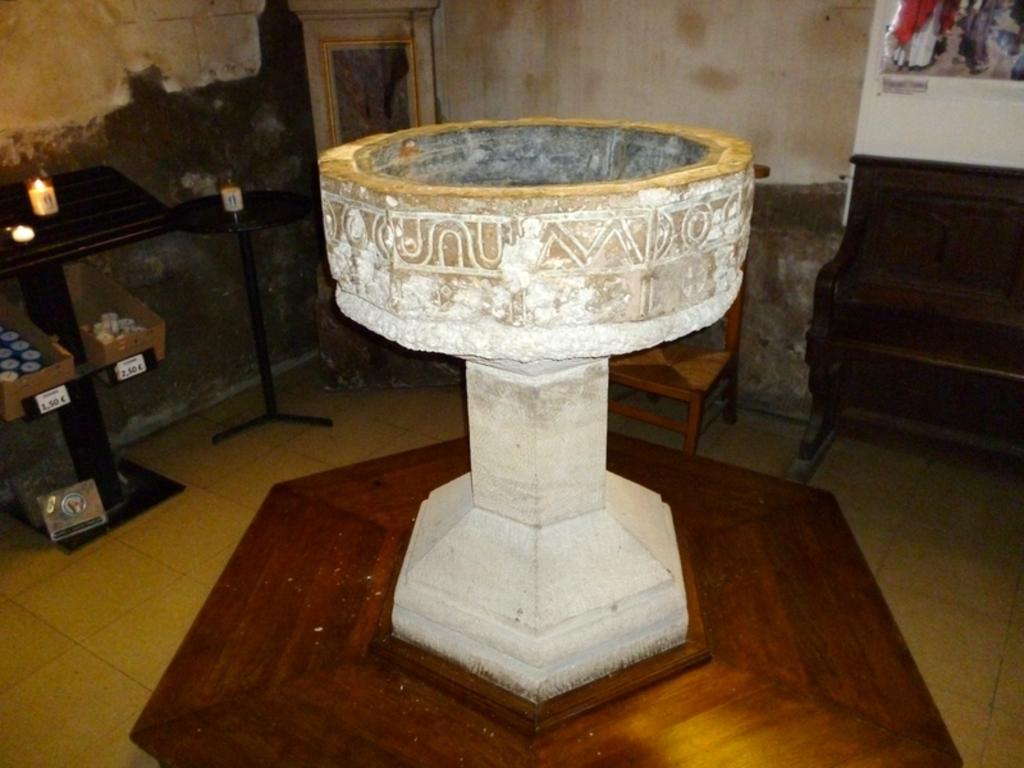In one or two sentences, can you explain what this image depicts? In the center of the image there is a stone structure. In the background of the image there is a wall. There is a table on which there are objects. To the right side of the image there is a bench. At the bottom of the image there is floor. 